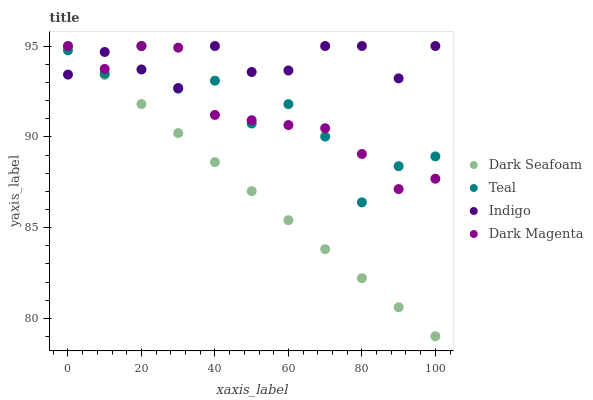Does Dark Seafoam have the minimum area under the curve?
Answer yes or no. Yes. Does Indigo have the maximum area under the curve?
Answer yes or no. Yes. Does Dark Magenta have the minimum area under the curve?
Answer yes or no. No. Does Dark Magenta have the maximum area under the curve?
Answer yes or no. No. Is Dark Seafoam the smoothest?
Answer yes or no. Yes. Is Teal the roughest?
Answer yes or no. Yes. Is Indigo the smoothest?
Answer yes or no. No. Is Indigo the roughest?
Answer yes or no. No. Does Dark Seafoam have the lowest value?
Answer yes or no. Yes. Does Dark Magenta have the lowest value?
Answer yes or no. No. Does Teal have the highest value?
Answer yes or no. Yes. Does Dark Seafoam intersect Dark Magenta?
Answer yes or no. Yes. Is Dark Seafoam less than Dark Magenta?
Answer yes or no. No. Is Dark Seafoam greater than Dark Magenta?
Answer yes or no. No. 